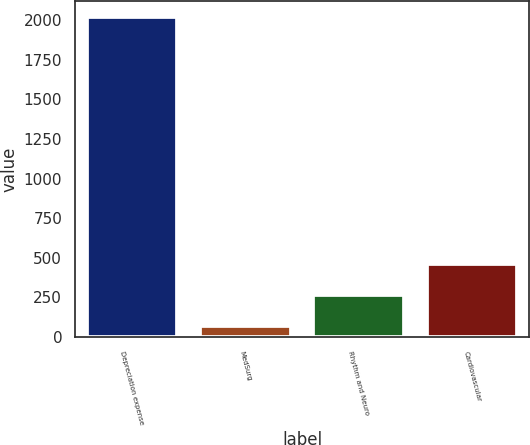Convert chart. <chart><loc_0><loc_0><loc_500><loc_500><bar_chart><fcel>Depreciation expense<fcel>MedSurg<fcel>Rhythm and Neuro<fcel>Cardiovascular<nl><fcel>2018<fcel>72<fcel>266.6<fcel>461.2<nl></chart> 